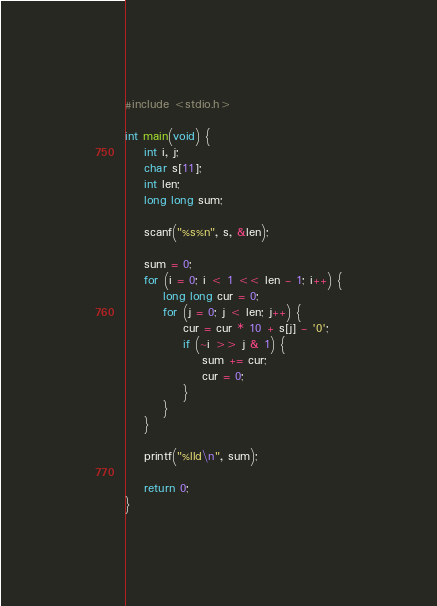<code> <loc_0><loc_0><loc_500><loc_500><_C_>#include <stdio.h>

int main(void) {
	int i, j;
	char s[11];
	int len;
	long long sum;

	scanf("%s%n", s, &len);

	sum = 0;
	for (i = 0; i < 1 << len - 1; i++) {
		long long cur = 0;
		for (j = 0; j < len; j++) {
			cur = cur * 10 + s[j] - '0';
			if (~i >> j & 1) {
				sum += cur;
				cur = 0;
			}
		}
	}

	printf("%lld\n", sum);

	return 0;
}
</code> 